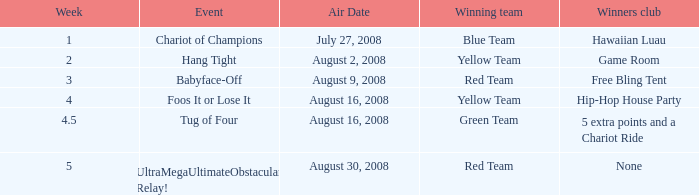Which champions club has an event of hold on? Game Room. Would you mind parsing the complete table? {'header': ['Week', 'Event', 'Air Date', 'Winning team', 'Winners club'], 'rows': [['1', 'Chariot of Champions', 'July 27, 2008', 'Blue Team', 'Hawaiian Luau'], ['2', 'Hang Tight', 'August 2, 2008', 'Yellow Team', 'Game Room'], ['3', 'Babyface-Off', 'August 9, 2008', 'Red Team', 'Free Bling Tent'], ['4', 'Foos It or Lose It', 'August 16, 2008', 'Yellow Team', 'Hip-Hop House Party'], ['4.5', 'Tug of Four', 'August 16, 2008', 'Green Team', '5 extra points and a Chariot Ride'], ['5', 'UltraMegaUltimateObstacular Relay!', 'August 30, 2008', 'Red Team', 'None']]} 